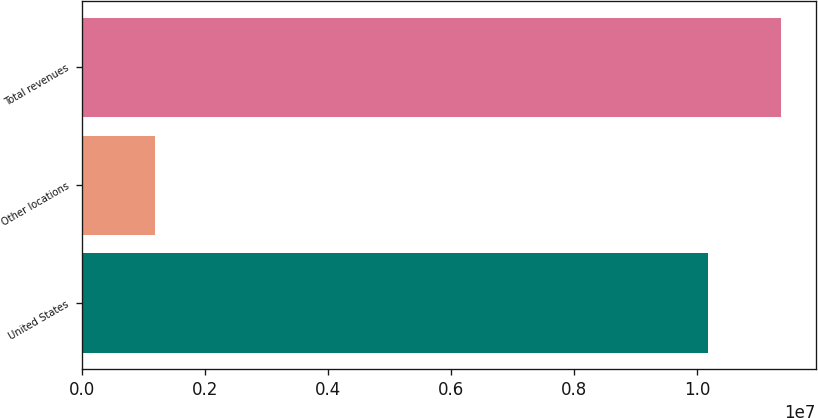Convert chart to OTSL. <chart><loc_0><loc_0><loc_500><loc_500><bar_chart><fcel>United States<fcel>Other locations<fcel>Total revenues<nl><fcel>1.01836e+07<fcel>1.17552e+06<fcel>1.13591e+07<nl></chart> 